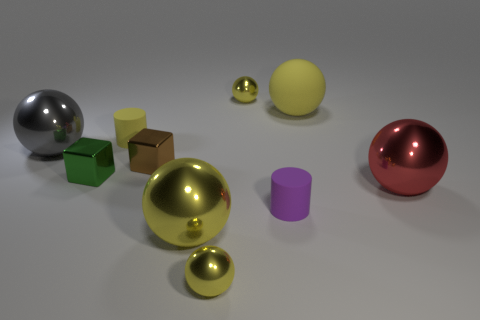Subtract all brown cylinders. How many yellow balls are left? 4 Subtract all red balls. How many balls are left? 5 Subtract all large gray spheres. How many spheres are left? 5 Subtract all purple balls. Subtract all purple blocks. How many balls are left? 6 Subtract all blocks. How many objects are left? 8 Subtract all small yellow balls. Subtract all yellow metal objects. How many objects are left? 5 Add 8 large yellow matte spheres. How many large yellow matte spheres are left? 9 Add 4 tiny brown blocks. How many tiny brown blocks exist? 5 Subtract 0 purple spheres. How many objects are left? 10 